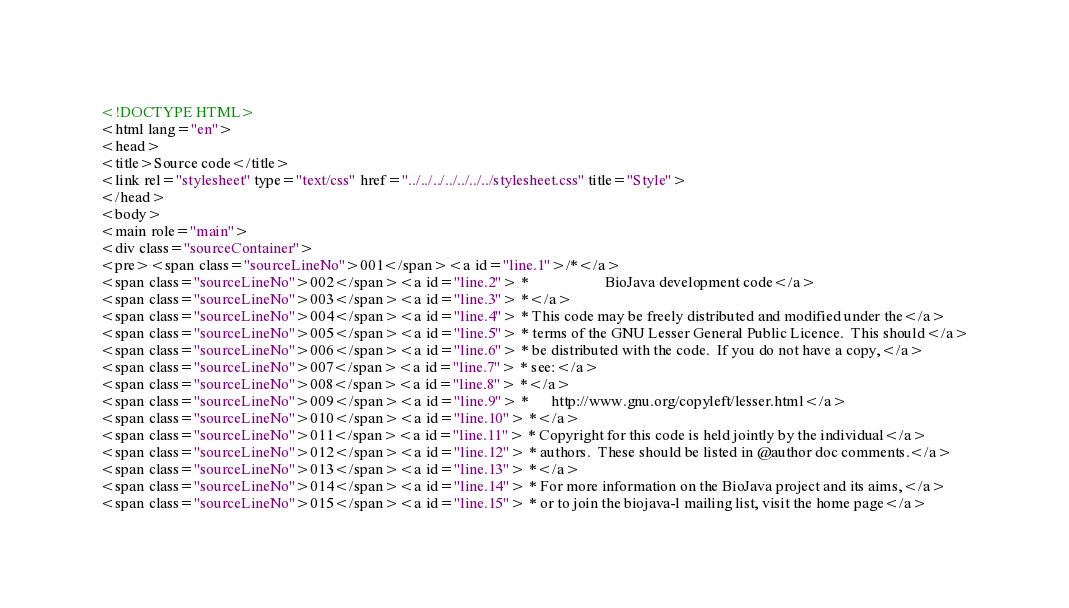<code> <loc_0><loc_0><loc_500><loc_500><_HTML_><!DOCTYPE HTML>
<html lang="en">
<head>
<title>Source code</title>
<link rel="stylesheet" type="text/css" href="../../../../../../../stylesheet.css" title="Style">
</head>
<body>
<main role="main">
<div class="sourceContainer">
<pre><span class="sourceLineNo">001</span><a id="line.1">/*</a>
<span class="sourceLineNo">002</span><a id="line.2"> *                    BioJava development code</a>
<span class="sourceLineNo">003</span><a id="line.3"> *</a>
<span class="sourceLineNo">004</span><a id="line.4"> * This code may be freely distributed and modified under the</a>
<span class="sourceLineNo">005</span><a id="line.5"> * terms of the GNU Lesser General Public Licence.  This should</a>
<span class="sourceLineNo">006</span><a id="line.6"> * be distributed with the code.  If you do not have a copy,</a>
<span class="sourceLineNo">007</span><a id="line.7"> * see:</a>
<span class="sourceLineNo">008</span><a id="line.8"> *</a>
<span class="sourceLineNo">009</span><a id="line.9"> *      http://www.gnu.org/copyleft/lesser.html</a>
<span class="sourceLineNo">010</span><a id="line.10"> *</a>
<span class="sourceLineNo">011</span><a id="line.11"> * Copyright for this code is held jointly by the individual</a>
<span class="sourceLineNo">012</span><a id="line.12"> * authors.  These should be listed in @author doc comments.</a>
<span class="sourceLineNo">013</span><a id="line.13"> *</a>
<span class="sourceLineNo">014</span><a id="line.14"> * For more information on the BioJava project and its aims,</a>
<span class="sourceLineNo">015</span><a id="line.15"> * or to join the biojava-l mailing list, visit the home page</a></code> 